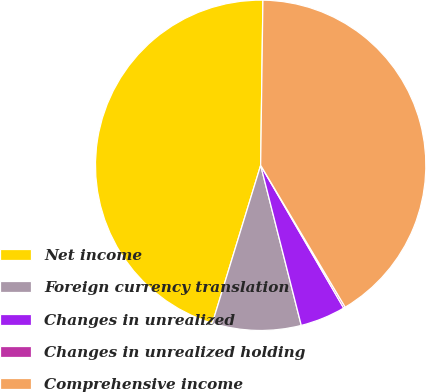Convert chart. <chart><loc_0><loc_0><loc_500><loc_500><pie_chart><fcel>Net income<fcel>Foreign currency translation<fcel>Changes in unrealized<fcel>Changes in unrealized holding<fcel>Comprehensive income<nl><fcel>45.49%<fcel>8.68%<fcel>4.43%<fcel>0.17%<fcel>41.23%<nl></chart> 